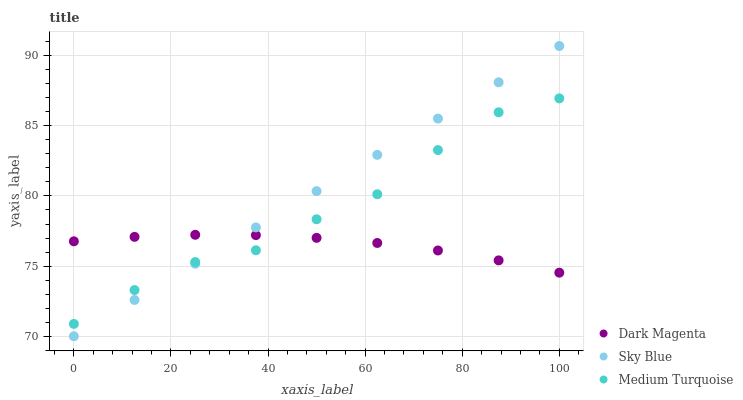Does Dark Magenta have the minimum area under the curve?
Answer yes or no. Yes. Does Sky Blue have the maximum area under the curve?
Answer yes or no. Yes. Does Medium Turquoise have the minimum area under the curve?
Answer yes or no. No. Does Medium Turquoise have the maximum area under the curve?
Answer yes or no. No. Is Sky Blue the smoothest?
Answer yes or no. Yes. Is Medium Turquoise the roughest?
Answer yes or no. Yes. Is Dark Magenta the smoothest?
Answer yes or no. No. Is Dark Magenta the roughest?
Answer yes or no. No. Does Sky Blue have the lowest value?
Answer yes or no. Yes. Does Medium Turquoise have the lowest value?
Answer yes or no. No. Does Sky Blue have the highest value?
Answer yes or no. Yes. Does Medium Turquoise have the highest value?
Answer yes or no. No. Does Medium Turquoise intersect Sky Blue?
Answer yes or no. Yes. Is Medium Turquoise less than Sky Blue?
Answer yes or no. No. Is Medium Turquoise greater than Sky Blue?
Answer yes or no. No. 